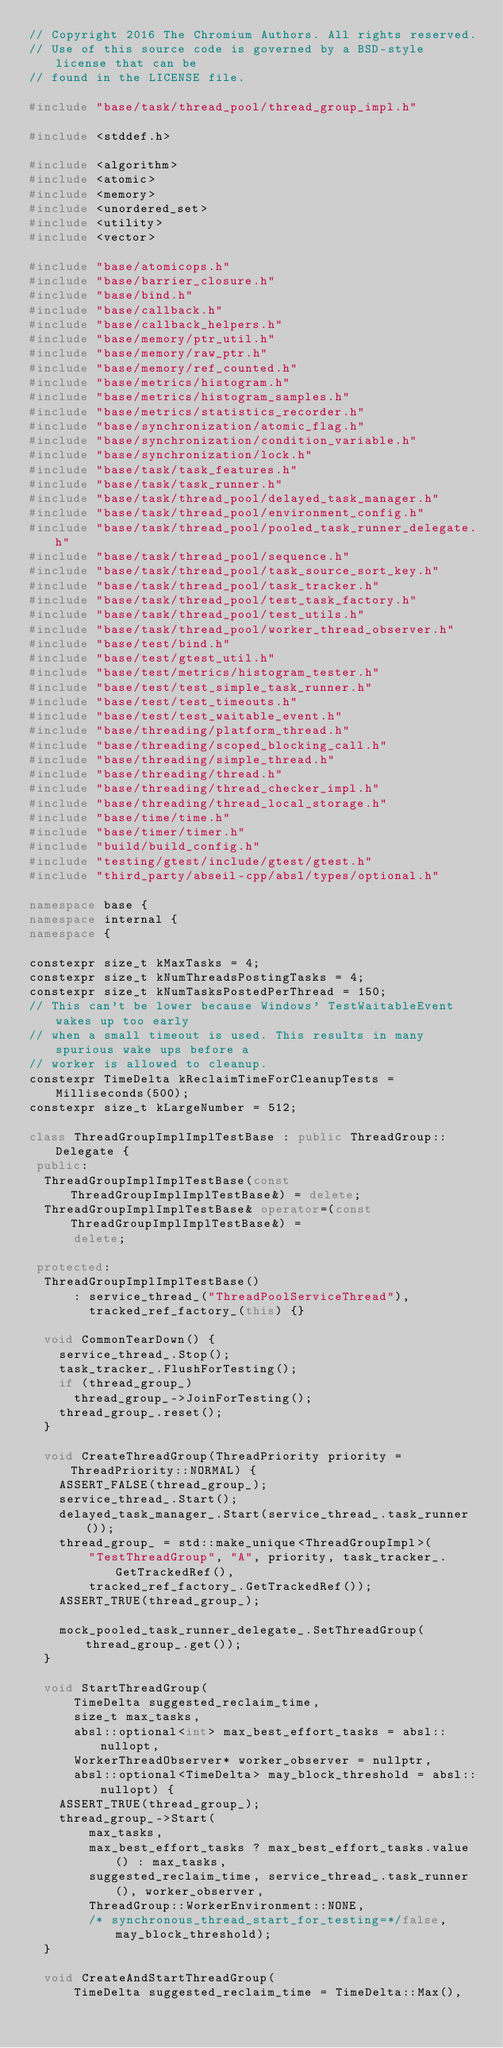Convert code to text. <code><loc_0><loc_0><loc_500><loc_500><_C++_>// Copyright 2016 The Chromium Authors. All rights reserved.
// Use of this source code is governed by a BSD-style license that can be
// found in the LICENSE file.

#include "base/task/thread_pool/thread_group_impl.h"

#include <stddef.h>

#include <algorithm>
#include <atomic>
#include <memory>
#include <unordered_set>
#include <utility>
#include <vector>

#include "base/atomicops.h"
#include "base/barrier_closure.h"
#include "base/bind.h"
#include "base/callback.h"
#include "base/callback_helpers.h"
#include "base/memory/ptr_util.h"
#include "base/memory/raw_ptr.h"
#include "base/memory/ref_counted.h"
#include "base/metrics/histogram.h"
#include "base/metrics/histogram_samples.h"
#include "base/metrics/statistics_recorder.h"
#include "base/synchronization/atomic_flag.h"
#include "base/synchronization/condition_variable.h"
#include "base/synchronization/lock.h"
#include "base/task/task_features.h"
#include "base/task/task_runner.h"
#include "base/task/thread_pool/delayed_task_manager.h"
#include "base/task/thread_pool/environment_config.h"
#include "base/task/thread_pool/pooled_task_runner_delegate.h"
#include "base/task/thread_pool/sequence.h"
#include "base/task/thread_pool/task_source_sort_key.h"
#include "base/task/thread_pool/task_tracker.h"
#include "base/task/thread_pool/test_task_factory.h"
#include "base/task/thread_pool/test_utils.h"
#include "base/task/thread_pool/worker_thread_observer.h"
#include "base/test/bind.h"
#include "base/test/gtest_util.h"
#include "base/test/metrics/histogram_tester.h"
#include "base/test/test_simple_task_runner.h"
#include "base/test/test_timeouts.h"
#include "base/test/test_waitable_event.h"
#include "base/threading/platform_thread.h"
#include "base/threading/scoped_blocking_call.h"
#include "base/threading/simple_thread.h"
#include "base/threading/thread.h"
#include "base/threading/thread_checker_impl.h"
#include "base/threading/thread_local_storage.h"
#include "base/time/time.h"
#include "base/timer/timer.h"
#include "build/build_config.h"
#include "testing/gtest/include/gtest/gtest.h"
#include "third_party/abseil-cpp/absl/types/optional.h"

namespace base {
namespace internal {
namespace {

constexpr size_t kMaxTasks = 4;
constexpr size_t kNumThreadsPostingTasks = 4;
constexpr size_t kNumTasksPostedPerThread = 150;
// This can't be lower because Windows' TestWaitableEvent wakes up too early
// when a small timeout is used. This results in many spurious wake ups before a
// worker is allowed to cleanup.
constexpr TimeDelta kReclaimTimeForCleanupTests = Milliseconds(500);
constexpr size_t kLargeNumber = 512;

class ThreadGroupImplImplTestBase : public ThreadGroup::Delegate {
 public:
  ThreadGroupImplImplTestBase(const ThreadGroupImplImplTestBase&) = delete;
  ThreadGroupImplImplTestBase& operator=(const ThreadGroupImplImplTestBase&) =
      delete;

 protected:
  ThreadGroupImplImplTestBase()
      : service_thread_("ThreadPoolServiceThread"),
        tracked_ref_factory_(this) {}

  void CommonTearDown() {
    service_thread_.Stop();
    task_tracker_.FlushForTesting();
    if (thread_group_)
      thread_group_->JoinForTesting();
    thread_group_.reset();
  }

  void CreateThreadGroup(ThreadPriority priority = ThreadPriority::NORMAL) {
    ASSERT_FALSE(thread_group_);
    service_thread_.Start();
    delayed_task_manager_.Start(service_thread_.task_runner());
    thread_group_ = std::make_unique<ThreadGroupImpl>(
        "TestThreadGroup", "A", priority, task_tracker_.GetTrackedRef(),
        tracked_ref_factory_.GetTrackedRef());
    ASSERT_TRUE(thread_group_);

    mock_pooled_task_runner_delegate_.SetThreadGroup(thread_group_.get());
  }

  void StartThreadGroup(
      TimeDelta suggested_reclaim_time,
      size_t max_tasks,
      absl::optional<int> max_best_effort_tasks = absl::nullopt,
      WorkerThreadObserver* worker_observer = nullptr,
      absl::optional<TimeDelta> may_block_threshold = absl::nullopt) {
    ASSERT_TRUE(thread_group_);
    thread_group_->Start(
        max_tasks,
        max_best_effort_tasks ? max_best_effort_tasks.value() : max_tasks,
        suggested_reclaim_time, service_thread_.task_runner(), worker_observer,
        ThreadGroup::WorkerEnvironment::NONE,
        /* synchronous_thread_start_for_testing=*/false, may_block_threshold);
  }

  void CreateAndStartThreadGroup(
      TimeDelta suggested_reclaim_time = TimeDelta::Max(),</code> 